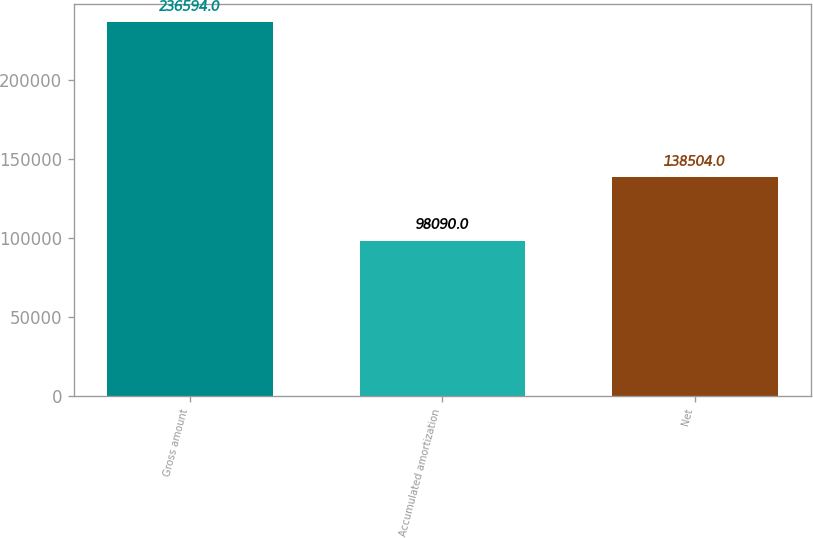<chart> <loc_0><loc_0><loc_500><loc_500><bar_chart><fcel>Gross amount<fcel>Accumulated amortization<fcel>Net<nl><fcel>236594<fcel>98090<fcel>138504<nl></chart> 